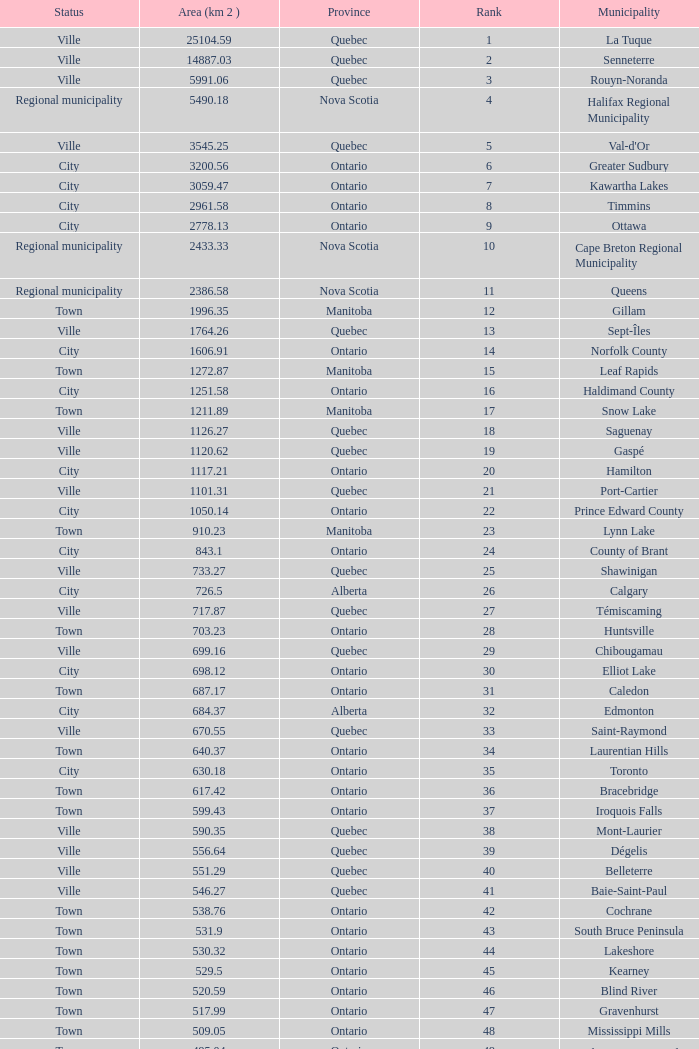What's the total of Rank that has an Area (KM 2) of 1050.14? 22.0. 